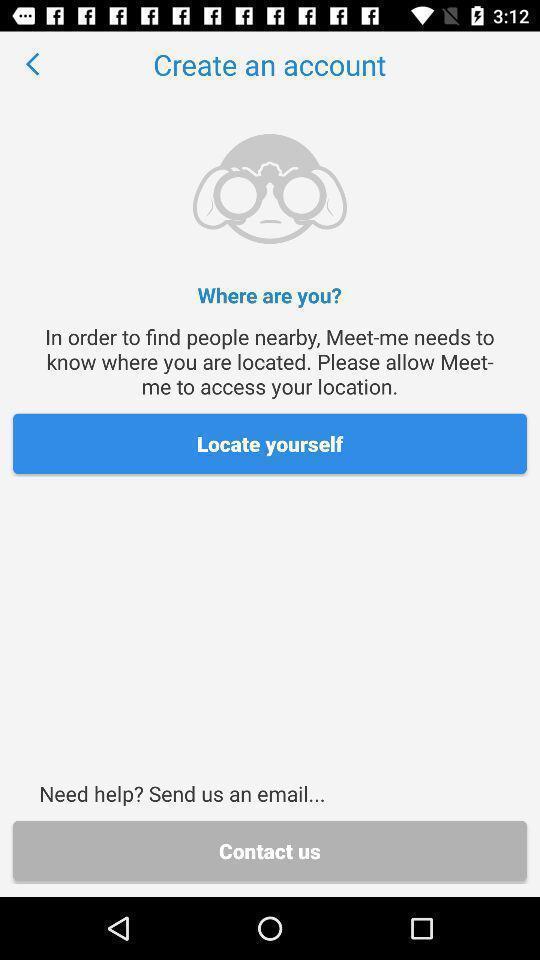Explain what's happening in this screen capture. Page to create an account with the current location. 